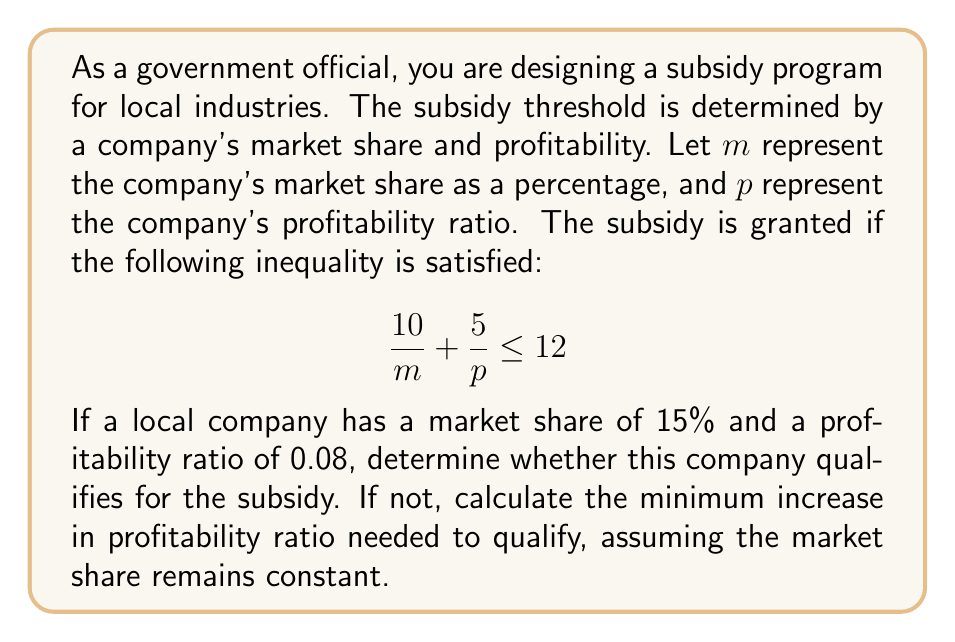Show me your answer to this math problem. Let's approach this problem step by step:

1) First, we need to check if the given values satisfy the inequality:

   $m = 15$ (15% market share)
   $p = 0.08$ (profitability ratio)

2) Substituting these values into the inequality:

   $$ \frac{10}{15} + \frac{5}{0.08} \leq 12 $$

3) Simplifying:

   $$ 0.6667 + 62.5 \leq 12 $$
   $$ 63.1667 \leq 12 $$

4) This inequality is not satisfied, as 63.1667 is greater than 12. Therefore, the company does not currently qualify for the subsidy.

5) To find the minimum increase in profitability needed, we need to solve the equation:

   $$ \frac{10}{15} + \frac{5}{p} = 12 $$

6) Simplifying:

   $$ 0.6667 + \frac{5}{p} = 12 $$
   $$ \frac{5}{p} = 11.3333 $$

7) Solving for $p$:

   $$ p = \frac{5}{11.3333} = 0.4412 $$

8) The current profitability is 0.08, so the minimum increase needed is:

   $$ 0.4412 - 0.08 = 0.3612 $$

Therefore, the company needs to increase its profitability ratio by at least 0.3612 to qualify for the subsidy, assuming the market share remains constant at 15%.
Answer: The company does not currently qualify for the subsidy. The minimum increase in profitability ratio needed to qualify is 0.3612, assuming the market share remains constant at 15%. 